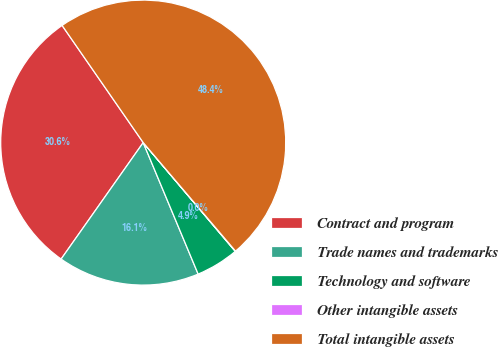<chart> <loc_0><loc_0><loc_500><loc_500><pie_chart><fcel>Contract and program<fcel>Trade names and trademarks<fcel>Technology and software<fcel>Other intangible assets<fcel>Total intangible assets<nl><fcel>30.59%<fcel>16.07%<fcel>4.88%<fcel>0.04%<fcel>48.42%<nl></chart> 